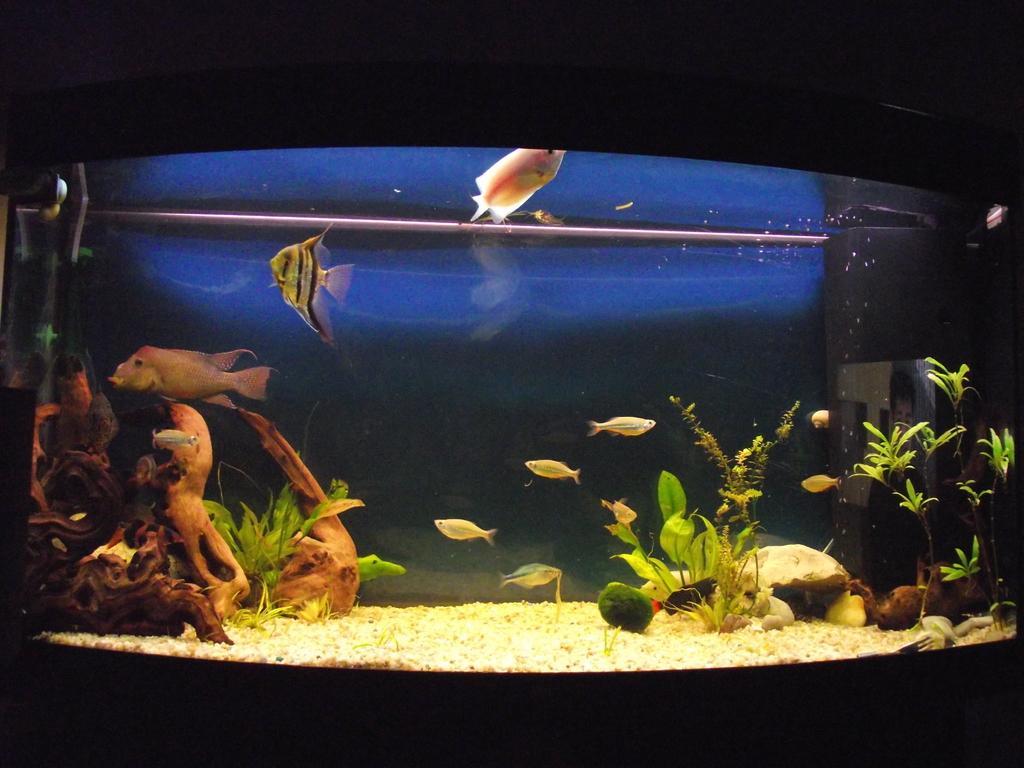How would you summarize this image in a sentence or two? In the image there is a beautiful aquarium and the background of the aquarium is dark. 